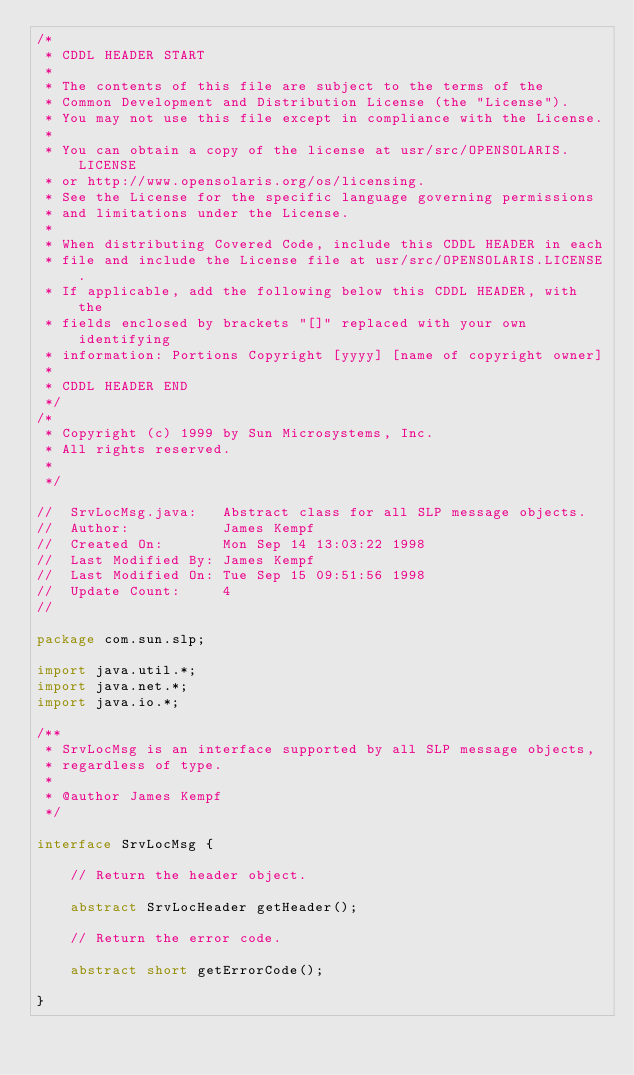Convert code to text. <code><loc_0><loc_0><loc_500><loc_500><_Java_>/*
 * CDDL HEADER START
 *
 * The contents of this file are subject to the terms of the
 * Common Development and Distribution License (the "License").
 * You may not use this file except in compliance with the License.
 *
 * You can obtain a copy of the license at usr/src/OPENSOLARIS.LICENSE
 * or http://www.opensolaris.org/os/licensing.
 * See the License for the specific language governing permissions
 * and limitations under the License.
 *
 * When distributing Covered Code, include this CDDL HEADER in each
 * file and include the License file at usr/src/OPENSOLARIS.LICENSE.
 * If applicable, add the following below this CDDL HEADER, with the
 * fields enclosed by brackets "[]" replaced with your own identifying
 * information: Portions Copyright [yyyy] [name of copyright owner]
 *
 * CDDL HEADER END
 */
/*
 * Copyright (c) 1999 by Sun Microsystems, Inc.
 * All rights reserved.
 *
 */

//  SrvLocMsg.java:   Abstract class for all SLP message objects.
//  Author:           James Kempf
//  Created On:       Mon Sep 14 13:03:22 1998
//  Last Modified By: James Kempf
//  Last Modified On: Tue Sep 15 09:51:56 1998
//  Update Count:     4
//

package com.sun.slp;

import java.util.*;
import java.net.*;
import java.io.*;

/**
 * SrvLocMsg is an interface supported by all SLP message objects,
 * regardless of type.
 *
 * @author James Kempf
 */

interface SrvLocMsg {

    // Return the header object.

    abstract SrvLocHeader getHeader();

    // Return the error code.

    abstract short getErrorCode();

}
</code> 